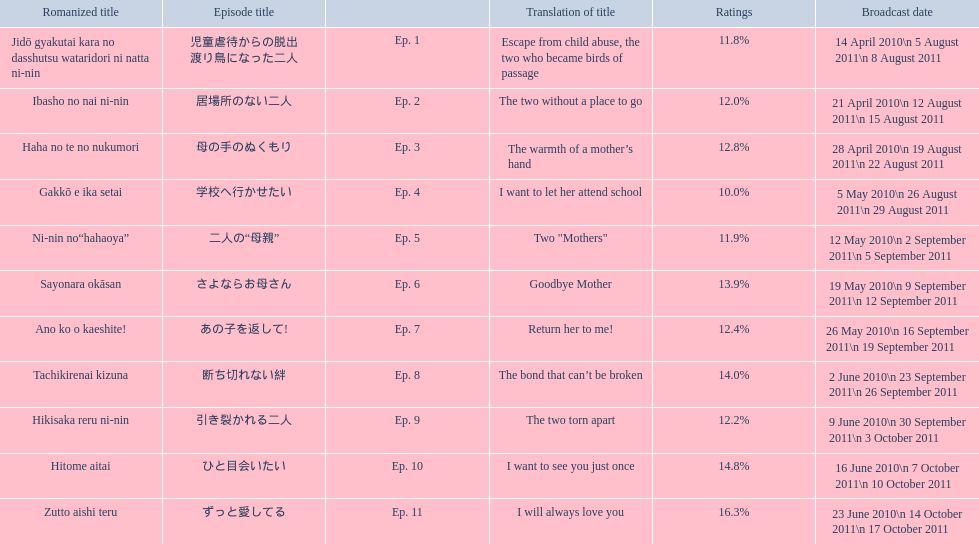What are the episodes of mother? 児童虐待からの脱出 渡り鳥になった二人, 居場所のない二人, 母の手のぬくもり, 学校へ行かせたい, 二人の“母親”, さよならお母さん, あの子を返して!, 断ち切れない絆, 引き裂かれる二人, ひと目会いたい, ずっと愛してる. What is the rating of episode 10? 14.8%. What is the other rating also in the 14 to 15 range? Ep. 8. 